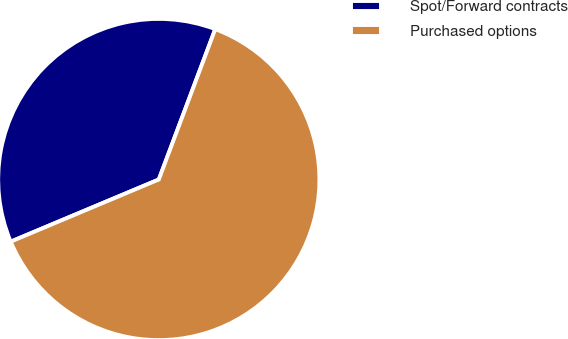<chart> <loc_0><loc_0><loc_500><loc_500><pie_chart><fcel>Spot/Forward contracts<fcel>Purchased options<nl><fcel>37.04%<fcel>62.96%<nl></chart> 